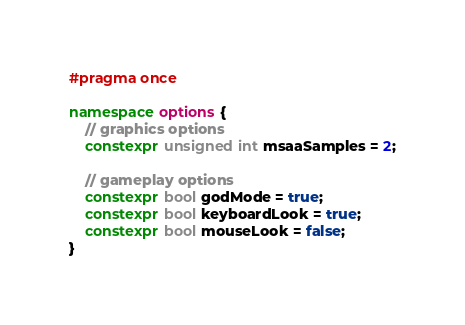Convert code to text. <code><loc_0><loc_0><loc_500><loc_500><_C++_>#pragma once

namespace options {
    // graphics options
    constexpr unsigned int msaaSamples = 2;

    // gameplay options
    constexpr bool godMode = true;
    constexpr bool keyboardLook = true;
	constexpr bool mouseLook = false;
}</code> 